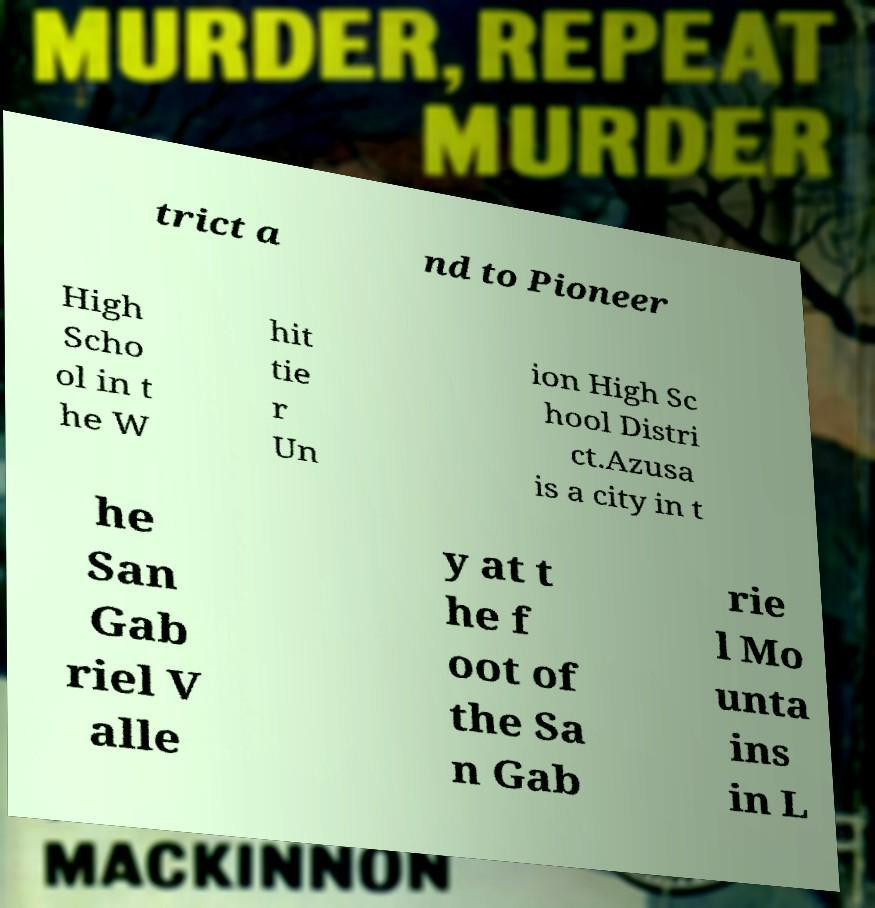For documentation purposes, I need the text within this image transcribed. Could you provide that? trict a nd to Pioneer High Scho ol in t he W hit tie r Un ion High Sc hool Distri ct.Azusa is a city in t he San Gab riel V alle y at t he f oot of the Sa n Gab rie l Mo unta ins in L 